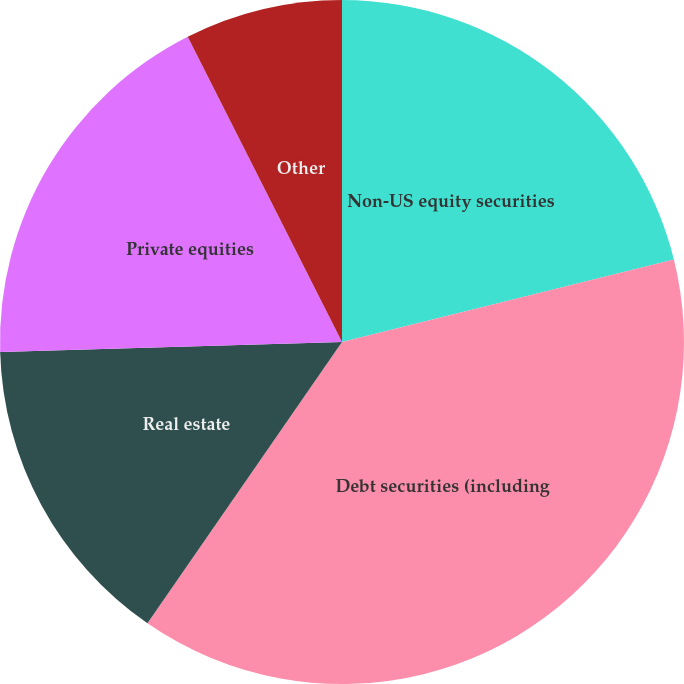<chart> <loc_0><loc_0><loc_500><loc_500><pie_chart><fcel>Non-US equity securities<fcel>Debt securities (including<fcel>Real estate<fcel>Private equities<fcel>Other<nl><fcel>21.12%<fcel>38.51%<fcel>14.91%<fcel>18.01%<fcel>7.45%<nl></chart> 